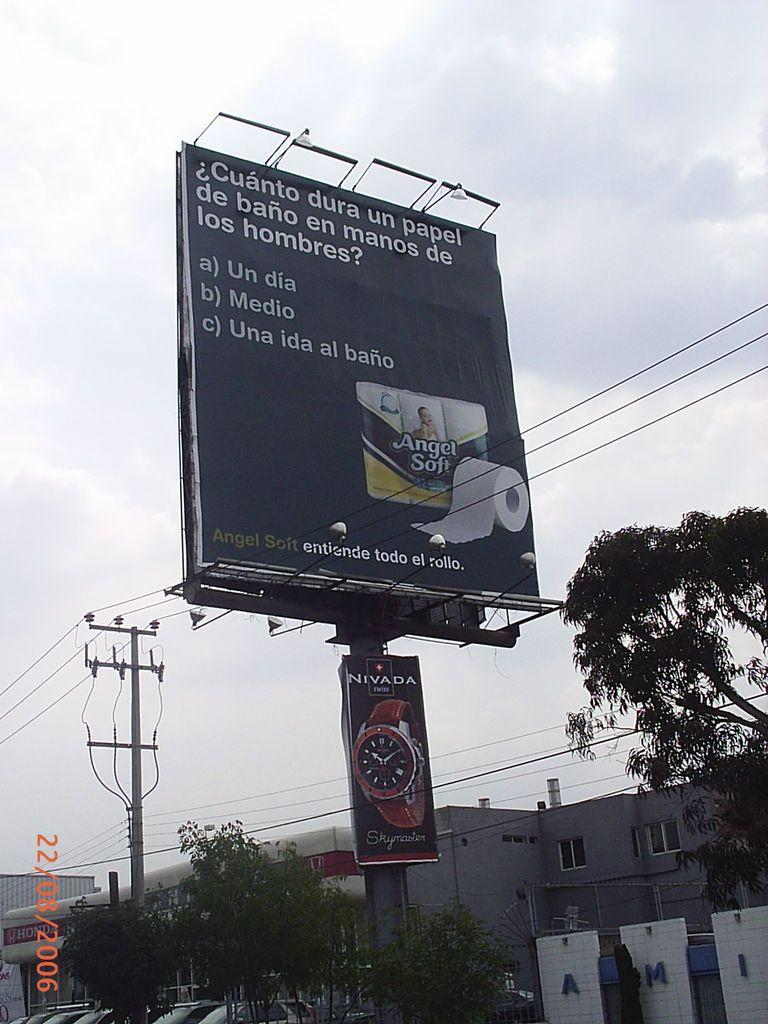<image>
Render a clear and concise summary of the photo. A billboard for Angel Soft toilet paper askes Cuanto dura un papel de bano en manos de los hombres. 